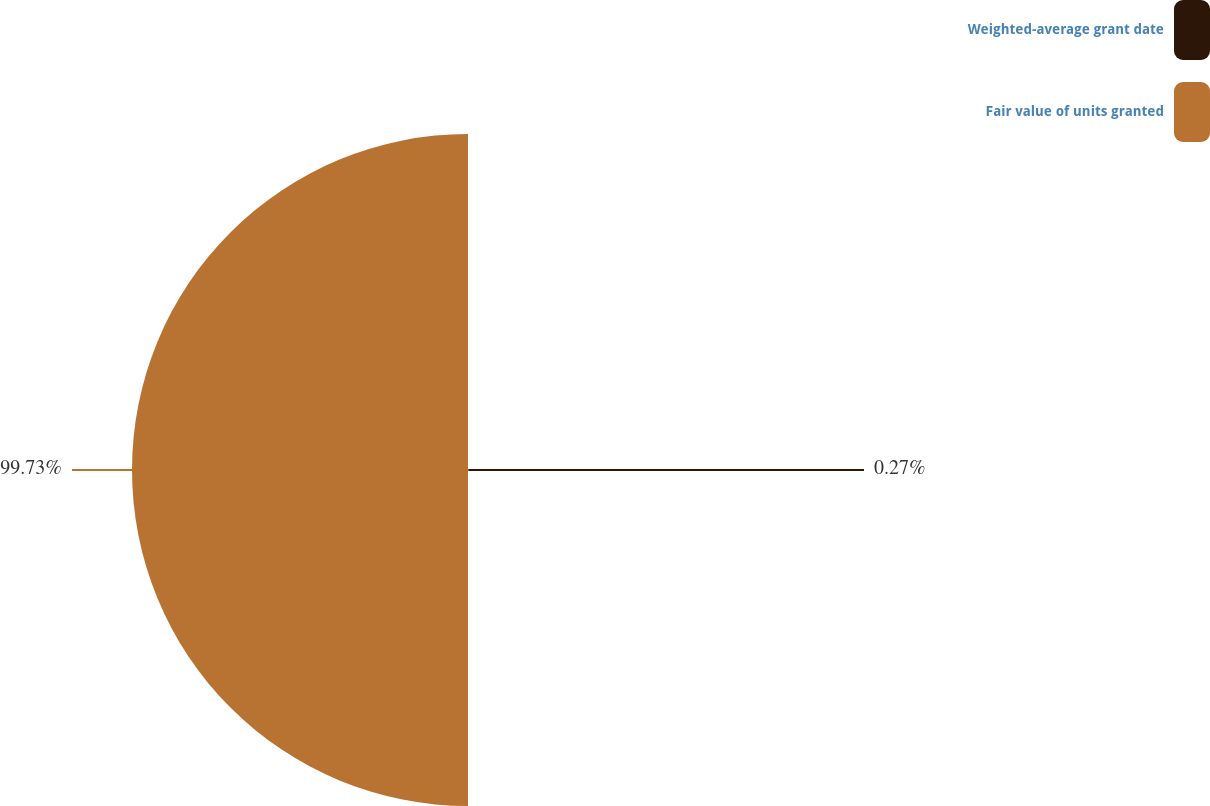<chart> <loc_0><loc_0><loc_500><loc_500><pie_chart><fcel>Weighted-average grant date<fcel>Fair value of units granted<nl><fcel>0.27%<fcel>99.73%<nl></chart> 